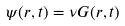Convert formula to latex. <formula><loc_0><loc_0><loc_500><loc_500>\psi ( r , t ) = \nu G ( r , t )</formula> 